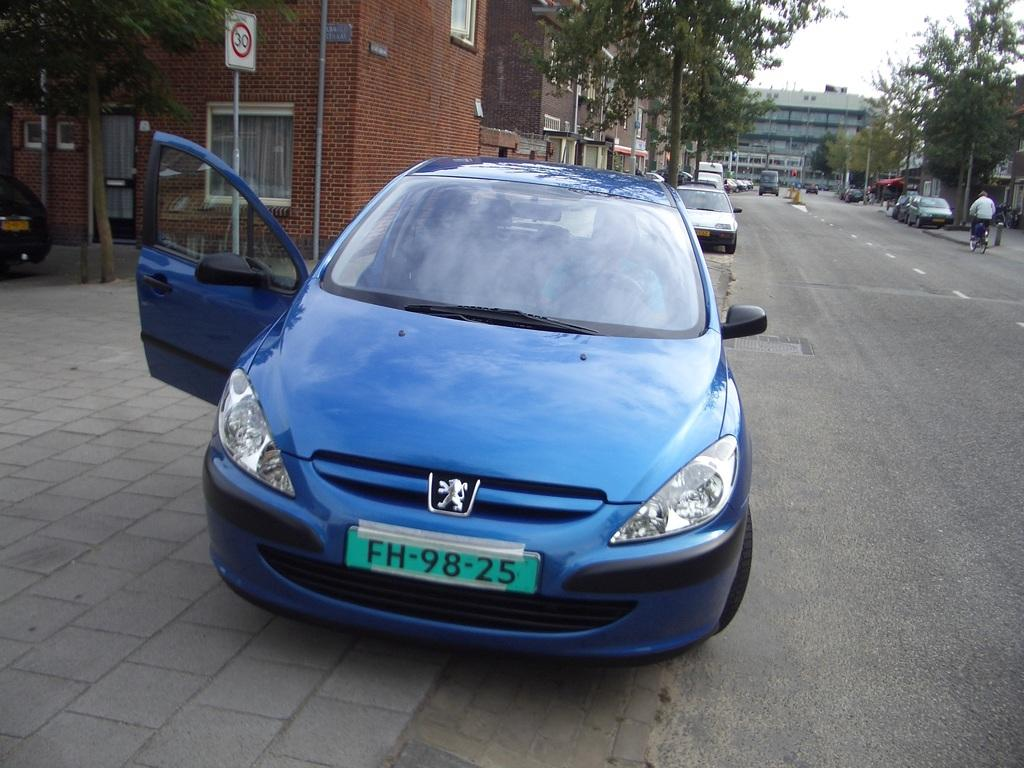<image>
Describe the image concisely. A blue car with license plate FH-98-25 has one door open. 